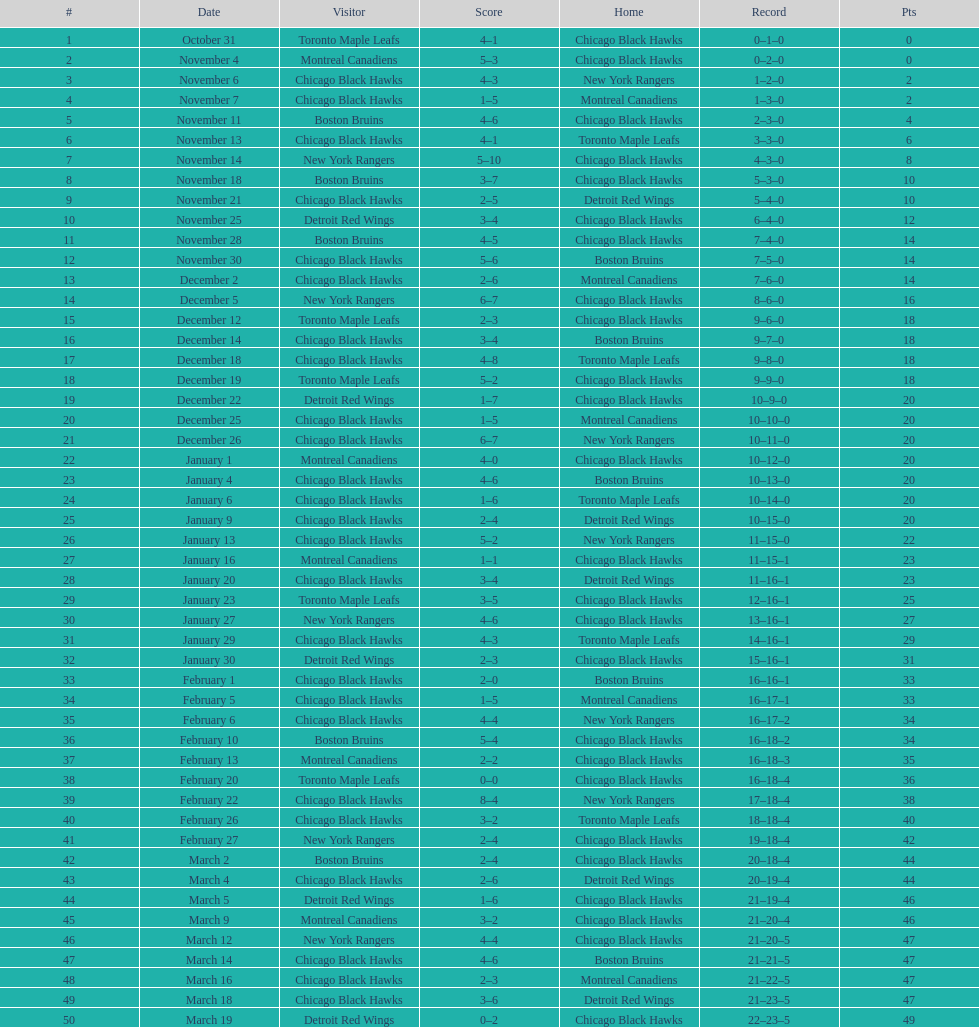Who was the next team that the boston bruins played after november 11? Chicago Black Hawks. 